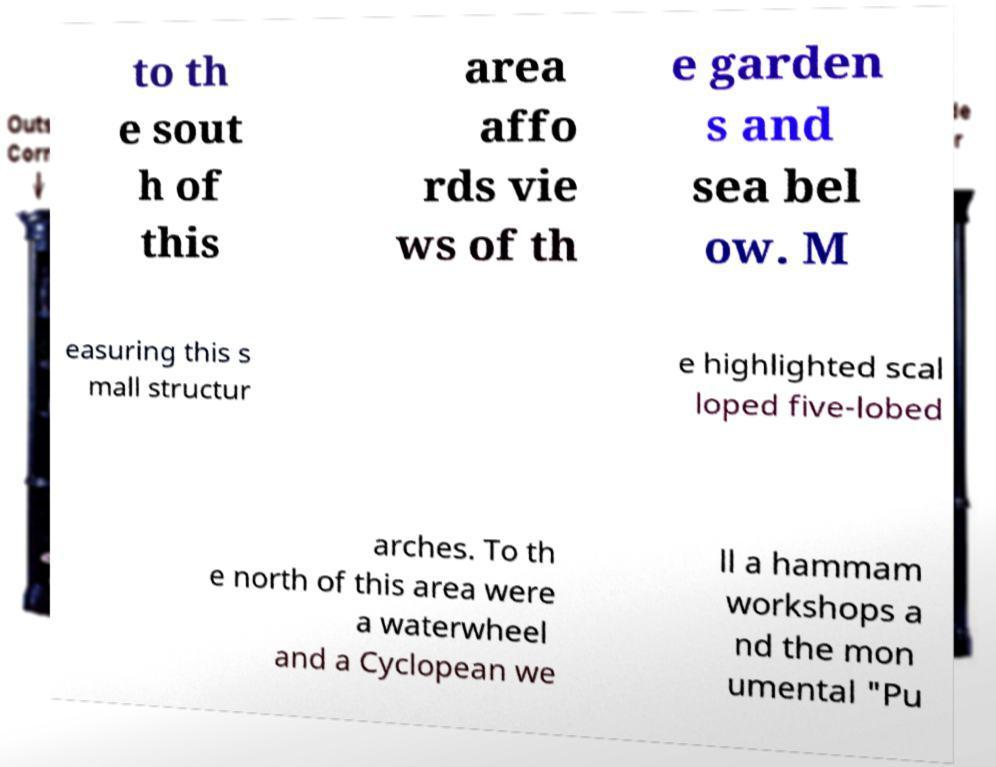Please read and relay the text visible in this image. What does it say? to th e sout h of this area affo rds vie ws of th e garden s and sea bel ow. M easuring this s mall structur e highlighted scal loped five-lobed arches. To th e north of this area were a waterwheel and a Cyclopean we ll a hammam workshops a nd the mon umental "Pu 